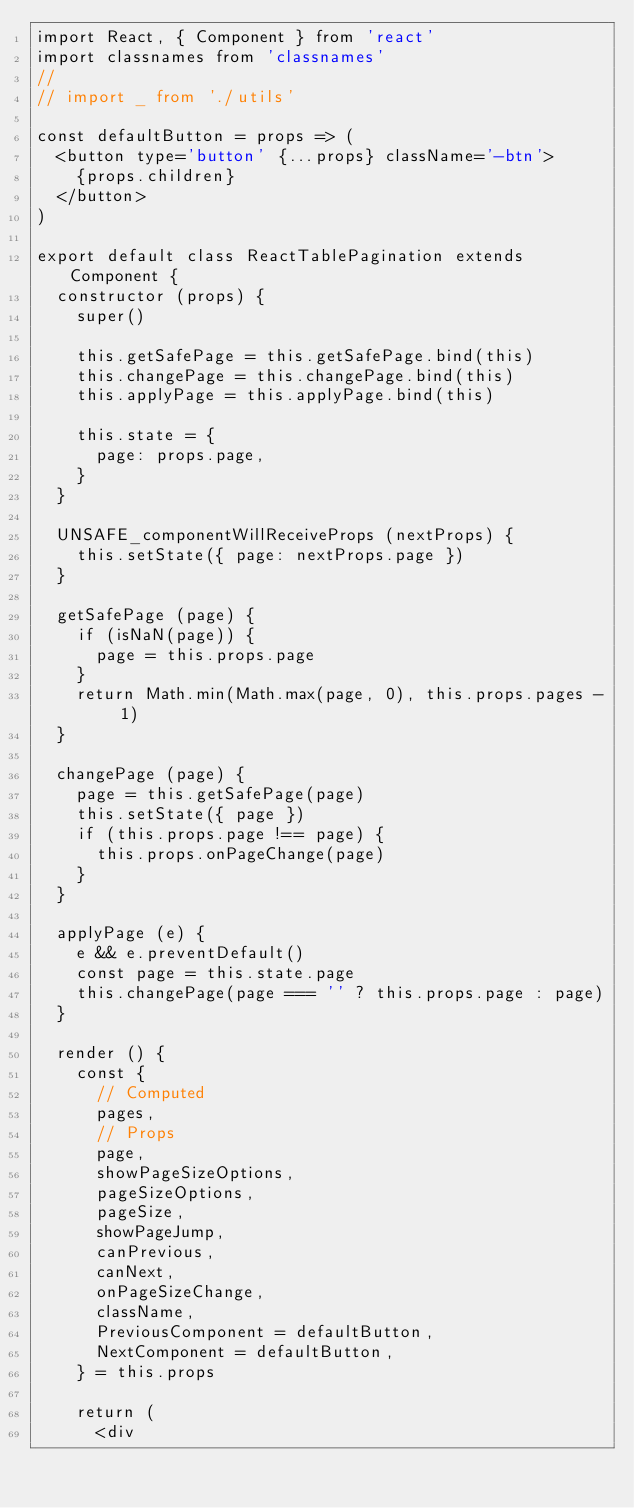Convert code to text. <code><loc_0><loc_0><loc_500><loc_500><_JavaScript_>import React, { Component } from 'react'
import classnames from 'classnames'
//
// import _ from './utils'

const defaultButton = props => (
  <button type='button' {...props} className='-btn'>
    {props.children}
  </button>
)

export default class ReactTablePagination extends Component {
  constructor (props) {
    super()

    this.getSafePage = this.getSafePage.bind(this)
    this.changePage = this.changePage.bind(this)
    this.applyPage = this.applyPage.bind(this)

    this.state = {
      page: props.page,
    }
  }

  UNSAFE_componentWillReceiveProps (nextProps) {
    this.setState({ page: nextProps.page })
  }

  getSafePage (page) {
    if (isNaN(page)) {
      page = this.props.page
    }
    return Math.min(Math.max(page, 0), this.props.pages - 1)
  }

  changePage (page) {
    page = this.getSafePage(page)
    this.setState({ page })
    if (this.props.page !== page) {
      this.props.onPageChange(page)
    }
  }

  applyPage (e) {
    e && e.preventDefault()
    const page = this.state.page
    this.changePage(page === '' ? this.props.page : page)
  }

  render () {
    const {
      // Computed
      pages,
      // Props
      page,
      showPageSizeOptions,
      pageSizeOptions,
      pageSize,
      showPageJump,
      canPrevious,
      canNext,
      onPageSizeChange,
      className,
      PreviousComponent = defaultButton,
      NextComponent = defaultButton,
    } = this.props

    return (
      <div</code> 